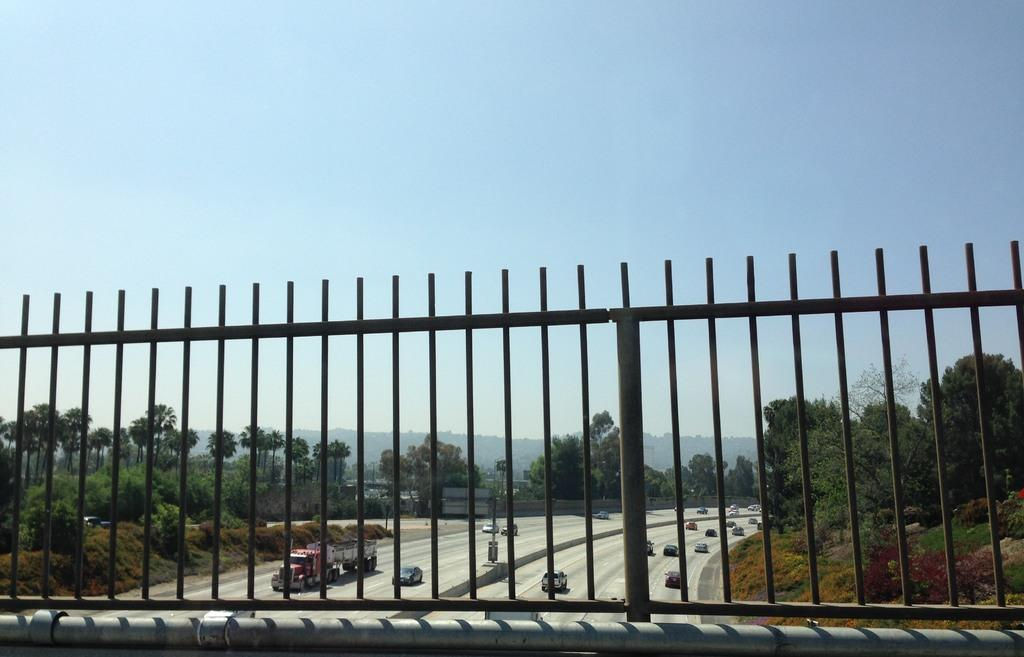What is located near the pipe in the image? There is a fencing near the pipe in the image. What can be seen in the background of the image? In the background, there are vehicles on the road, trees, plants, grass, and a mountain. What is the color of the sky in the image? The sky is blue in the image. Can you tell me how many carpenters are working on the mountain in the image? A: There are no carpenters present in the image, and no work is being done on the mountain. What type of pollution can be seen in the image? There is no pollution visible in the image. 